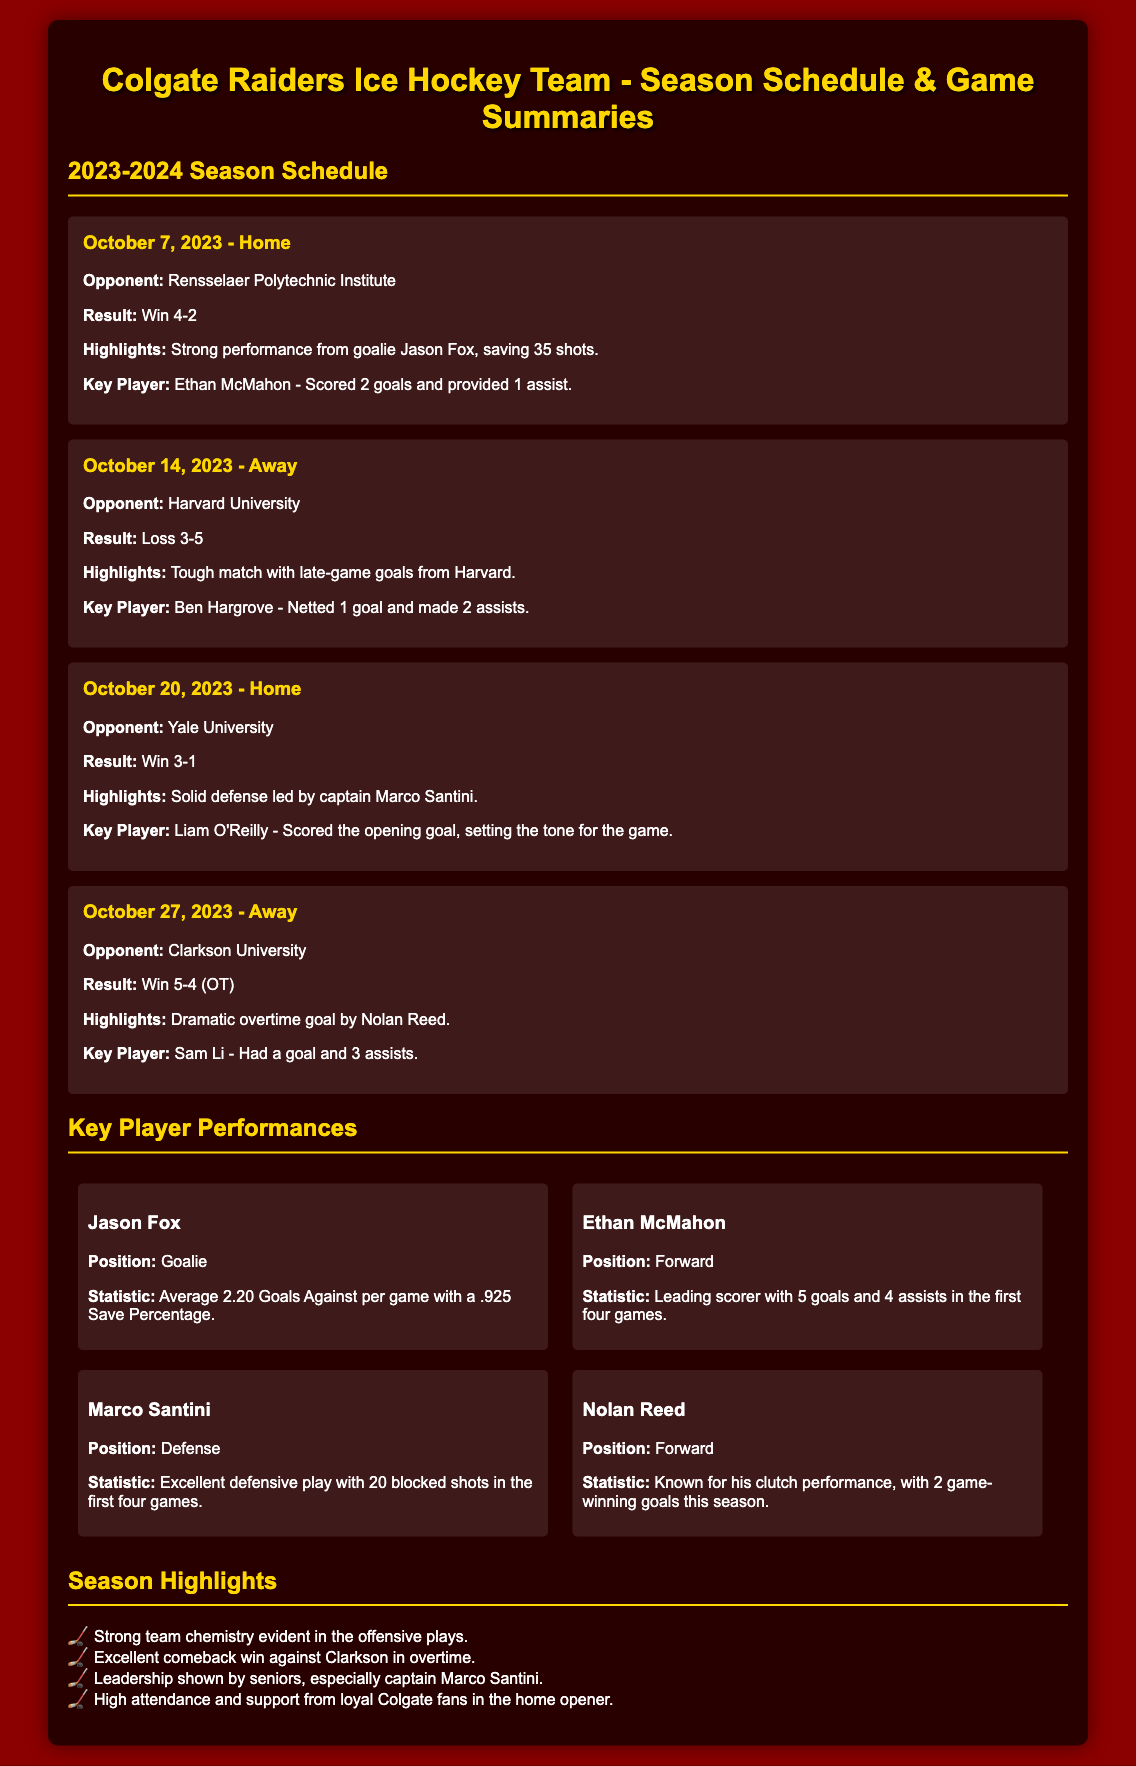What was the score of the game against Harvard University? The score is listed under the game summary for October 14, 2023, which shows a loss.
Answer: 3-5 Who scored the opening goal against Yale University? The key player performance for the game on October 20, 2023, indicates who scored the opening goal.
Answer: Liam O'Reilly How many goals did Ethan McMahon score in the first four games? The key player performance for Ethan McMahon states his scoring record during this period.
Answer: 5 goals What position does Marco Santini play? This information is provided in the key player performance section for Marco Santini.
Answer: Defense Which team did Colgate Raiders have a dramatic win against in overtime? The game summary for October 27, 2023, mentions this dramatic win.
Answer: Clarkson University What is the average goals against per game for Jason Fox? This statistic is noted in the key player performance section for Jason Fox.
Answer: 2.20 Goals Against per game How many blocked shots did Marco Santini have in the first four games? The statistic for Marco Santini’s defensive play is provided in his player card.
Answer: 20 blocked shots What key highlight is mentioned regarding team chemistry? This is listed in the season highlights section of the document.
Answer: Strong team chemistry evident in the offensive plays 